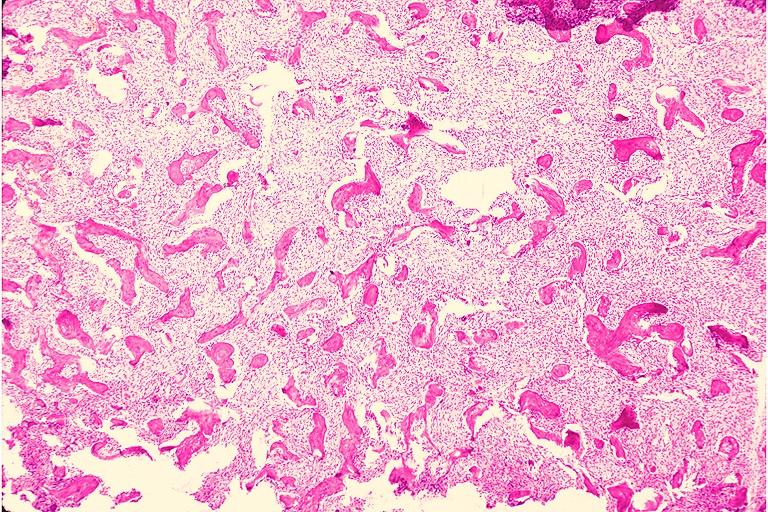where is this?
Answer the question using a single word or phrase. Oral 